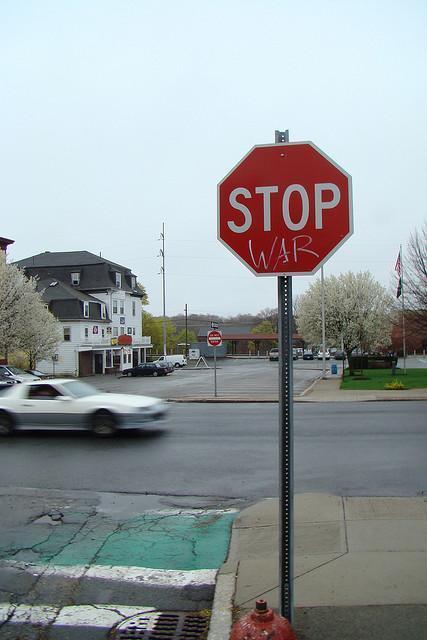How many cars are on the street?
Give a very brief answer. 1. How many different colors were used for all the graffiti?
Give a very brief answer. 1. How many ways must stop?
Give a very brief answer. 1. How many cars are in the picture?
Give a very brief answer. 1. How many stop signs?
Give a very brief answer. 1. 